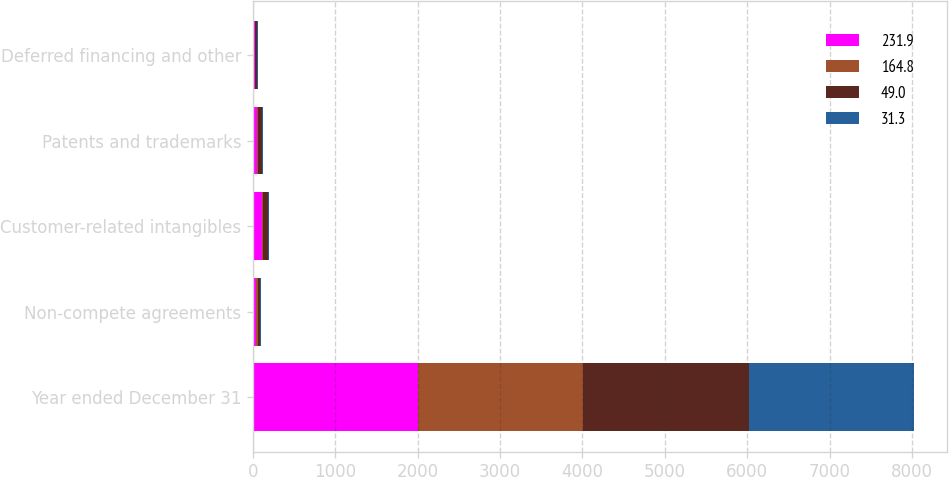<chart> <loc_0><loc_0><loc_500><loc_500><stacked_bar_chart><ecel><fcel>Year ended December 31<fcel>Non-compete agreements<fcel>Customer-related intangibles<fcel>Patents and trademarks<fcel>Deferred financing and other<nl><fcel>231.9<fcel>2006<fcel>44.1<fcel>112.4<fcel>53.5<fcel>21.9<nl><fcel>164.8<fcel>2006<fcel>14.3<fcel>11.6<fcel>15.2<fcel>7.9<nl><fcel>49<fcel>2005<fcel>29.5<fcel>64.7<fcel>48<fcel>22.6<nl><fcel>31.3<fcel>2005<fcel>9.5<fcel>3.6<fcel>11.4<fcel>6.8<nl></chart> 